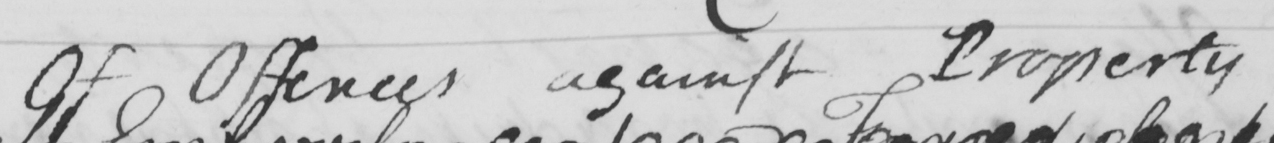Can you tell me what this handwritten text says? Of Offences against Property 